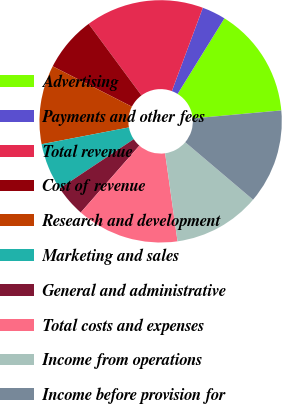Convert chart to OTSL. <chart><loc_0><loc_0><loc_500><loc_500><pie_chart><fcel>Advertising<fcel>Payments and other fees<fcel>Total revenue<fcel>Cost of revenue<fcel>Research and development<fcel>Marketing and sales<fcel>General and administrative<fcel>Total costs and expenses<fcel>Income from operations<fcel>Income before provision for<nl><fcel>14.74%<fcel>3.16%<fcel>15.79%<fcel>7.37%<fcel>10.53%<fcel>6.32%<fcel>4.21%<fcel>13.68%<fcel>11.58%<fcel>12.63%<nl></chart> 